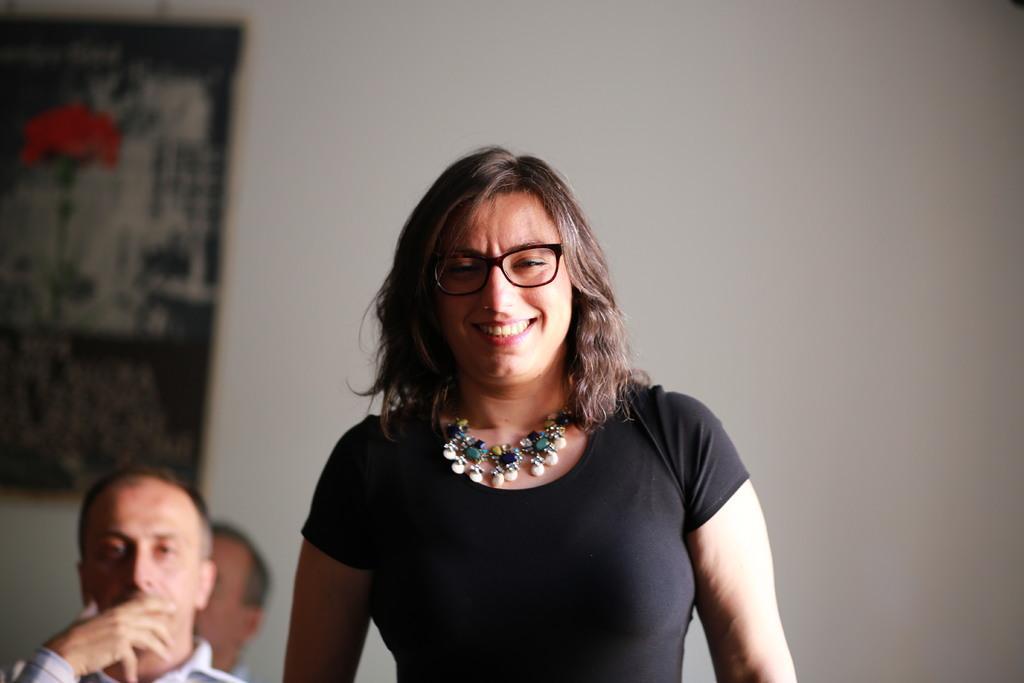Could you give a brief overview of what you see in this image? In the background we can see a frame on the wall. In this picture we can see a woman, wearing spectacles, necklace, black dress. She is smiling. On the left side we can see men. 